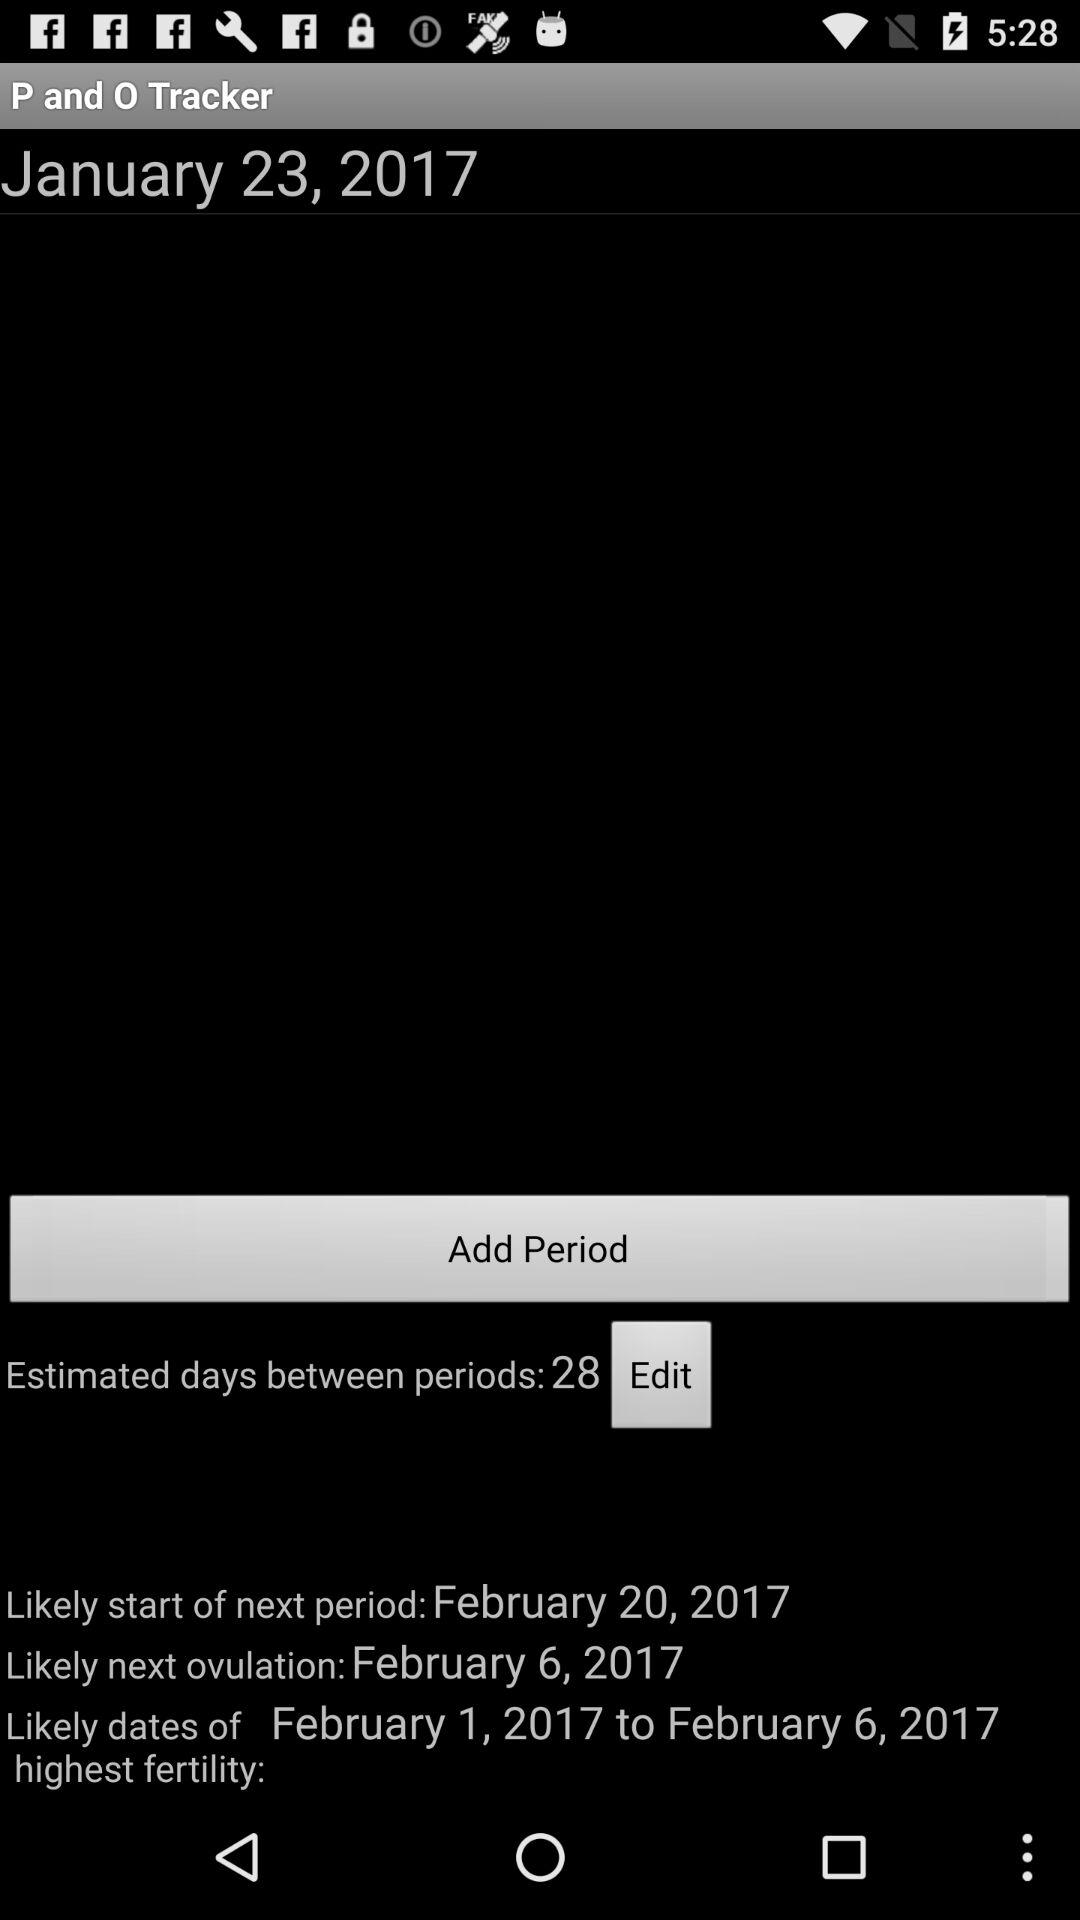What is the current date? The current date is January 23, 2017. 